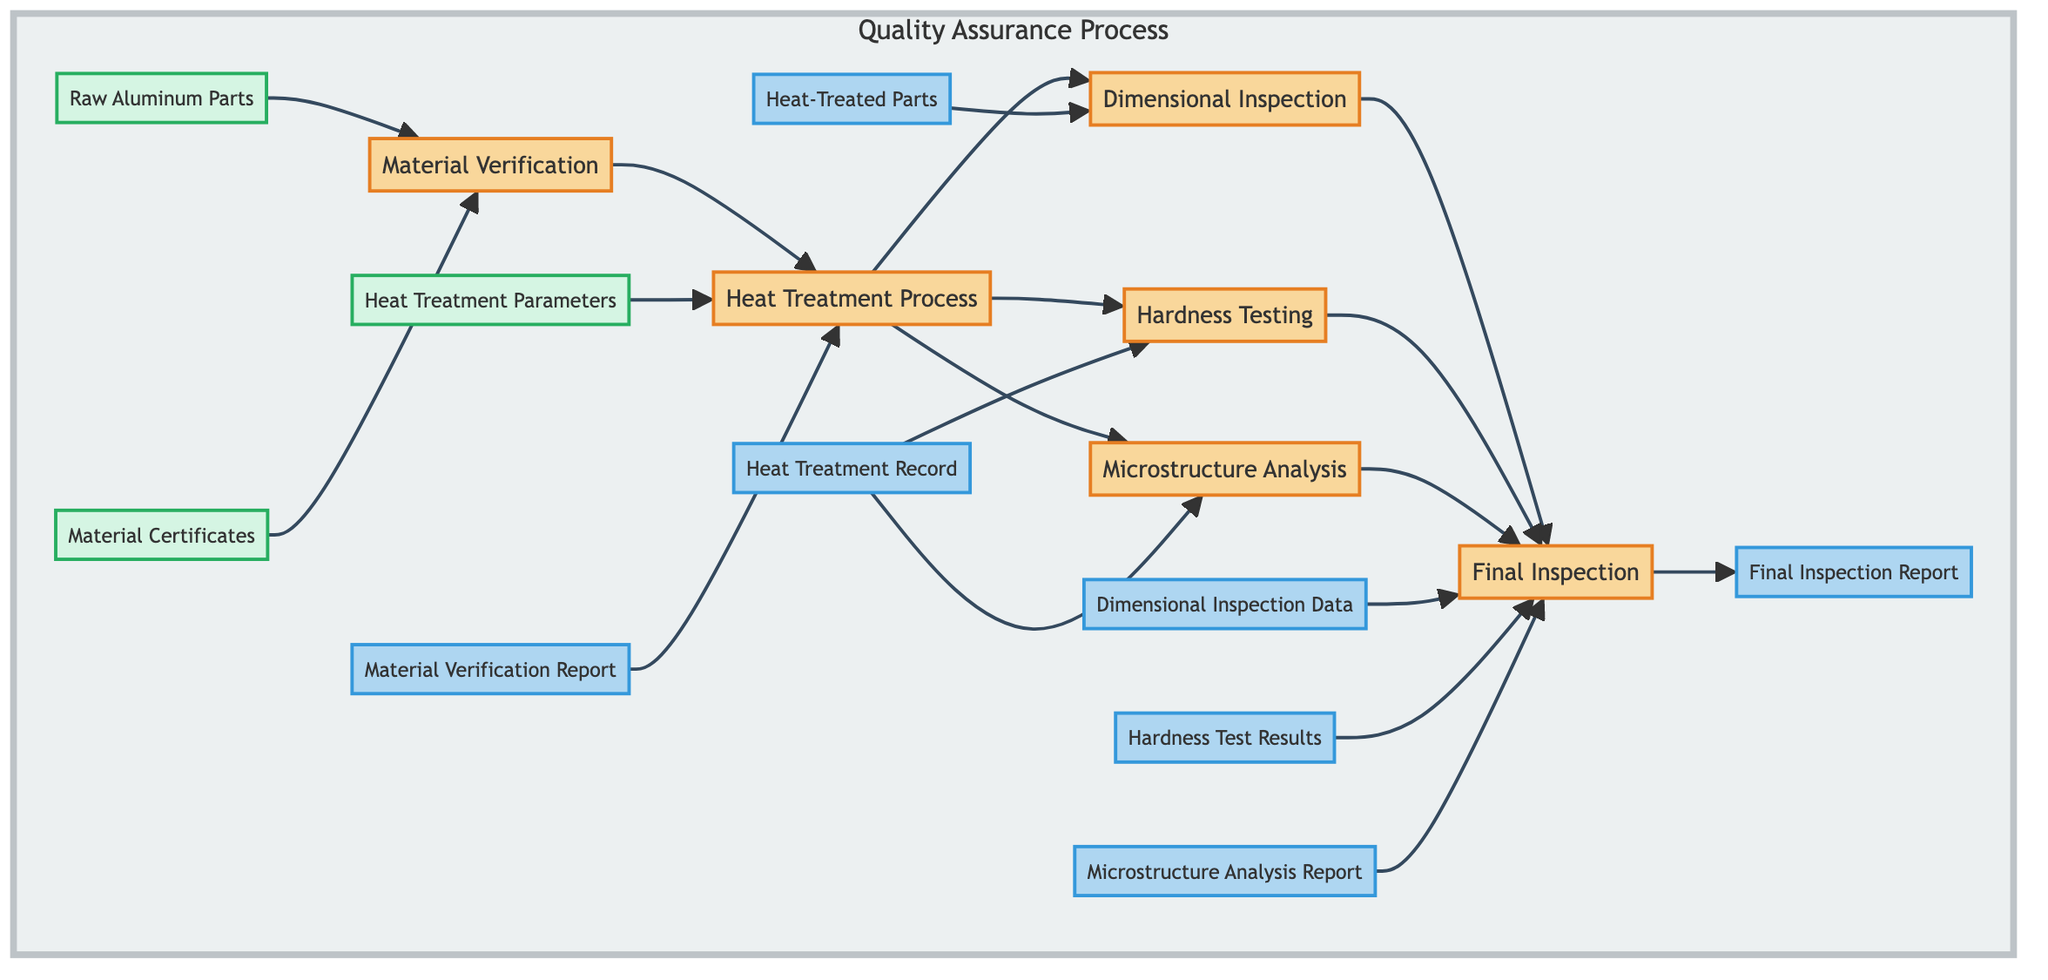What is the final output of the Quality Assurance process? The final output of the Quality Assurance process is the "Final Inspection Report," as indicated by the last output node in the flow chart.
Answer: Final Inspection Report How many inputs are associated with the "Material Verification" process? The "Material Verification" process has two inputs: "Raw Aluminum Parts" and "Material Certificates," as shown in the diagram.
Answer: 2 Who is responsible for the "Hardness Testing"? The "Testing Lab" is responsible for the "Hardness Testing," as stated in the diagram under the "Hardness Testing" node.
Answer: Testing Lab What is the first step in the Quality Assurance process? The first step in the Quality Assurance process is "Material Verification," which is the initial node that starts the flow of processes.
Answer: Material Verification What outputs are generated from the "Heat Treatment Process"? The "Heat Treatment Process" generates three outputs: "Heat-Treated Parts," "Heat Treatment Record," and it also serves as an input for "Hardness Testing" and "Microstructure Analysis," indicating its role in the flow.
Answer: Heat-Treated Parts, Heat Treatment Record How many total processes are depicted in the flow chart? The flow chart includes six distinct processes: "Final Inspection," "Microstructure Analysis," "Hardness Testing," "Dimensional Inspection," "Heat Treatment Process," and "Material Verification." Therefore, the total number of processes is six.
Answer: 6 What is required before conducting the "Final Inspection"? Before conducting the "Final Inspection," the processes "Dimensional Inspection," "Hardness Testing," and "Microstructure Analysis" must be completed, as each process provides necessary outputs for this final inspection.
Answer: Dimensional Inspection, Hardness Testing, Microstructure Analysis Which department is responsible for the "Heat Treatment Process"? The "Heat Treatment Department" is specified as the responsible party for conducting the "Heat Treatment Process," according to the responsibilities listed in the diagram.
Answer: Heat Treatment Department 